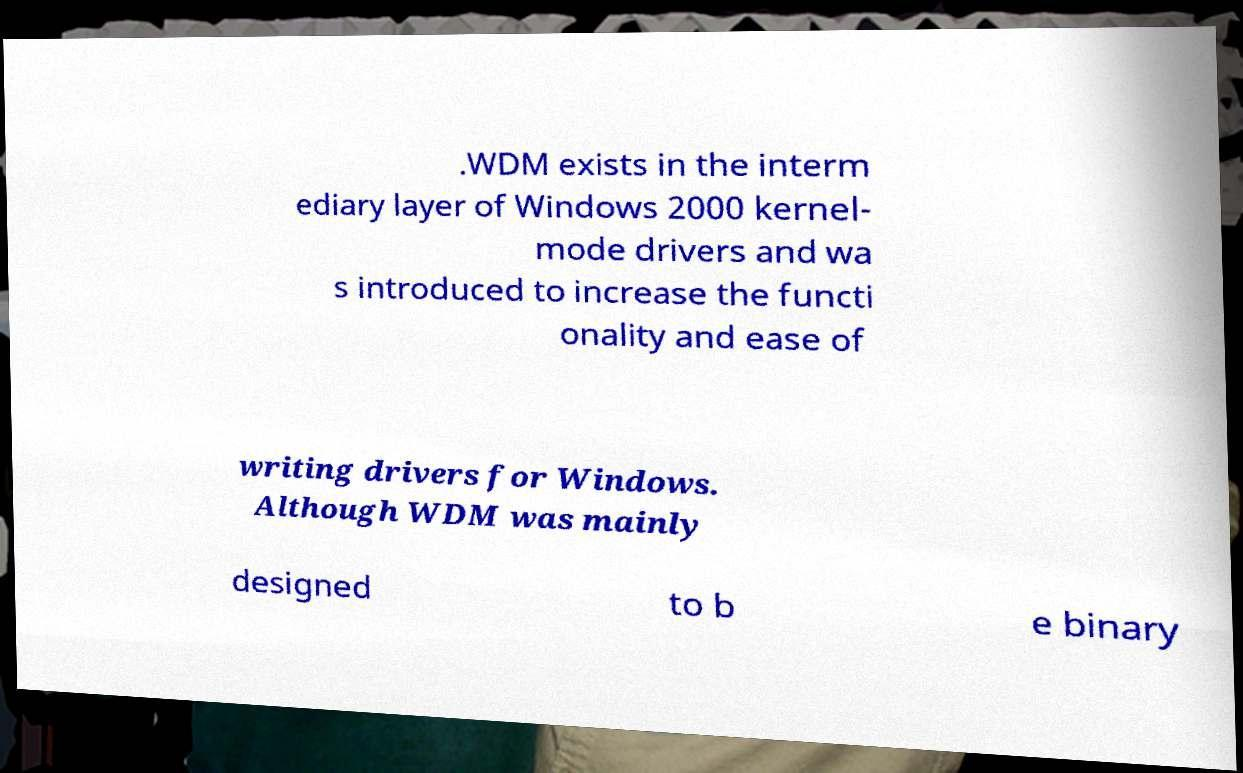What messages or text are displayed in this image? I need them in a readable, typed format. .WDM exists in the interm ediary layer of Windows 2000 kernel- mode drivers and wa s introduced to increase the functi onality and ease of writing drivers for Windows. Although WDM was mainly designed to b e binary 